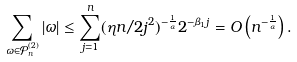Convert formula to latex. <formula><loc_0><loc_0><loc_500><loc_500>\sum _ { \omega \in \mathcal { P } ^ { ( 2 ) } _ { n } } | \omega | \leq \sum _ { j = 1 } ^ { n } ( \eta n / 2 j ^ { 2 } ) ^ { - \frac { 1 } { \alpha } } 2 ^ { - \beta _ { 1 } j } = O \left ( n ^ { - \frac { 1 } { \alpha } } \right ) .</formula> 